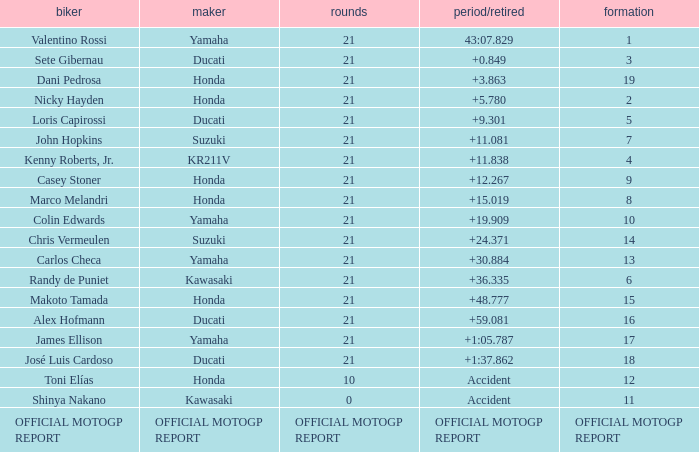When rider John Hopkins had 21 laps, what was the grid? 7.0. 